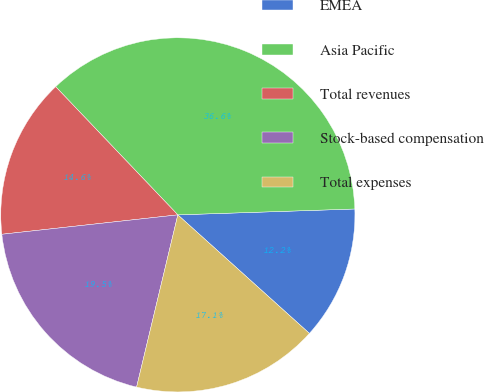Convert chart. <chart><loc_0><loc_0><loc_500><loc_500><pie_chart><fcel>EMEA<fcel>Asia Pacific<fcel>Total revenues<fcel>Stock-based compensation<fcel>Total expenses<nl><fcel>12.2%<fcel>36.59%<fcel>14.63%<fcel>19.51%<fcel>17.07%<nl></chart> 